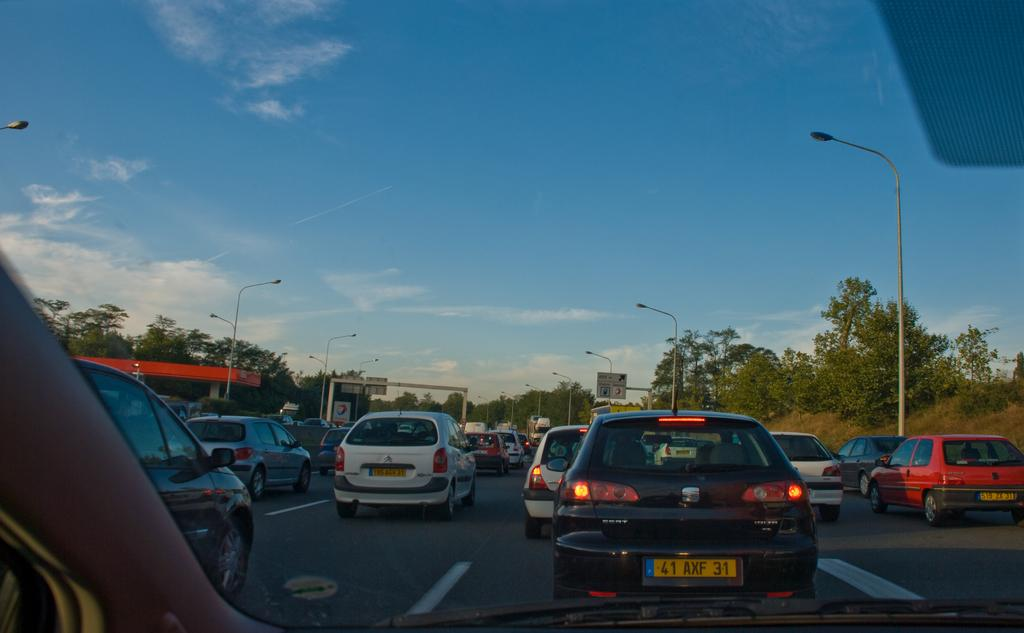What can be seen on the road in the image? There is a group of vehicles on the road in the image. What architectural feature is present in the image? There is a roof with a pillar in the image. What type of structures can be seen along the road? There are street poles in the image. What type of information might be conveyed by the objects in the image? There are signboards in the image, which might convey information or directions. What type of vegetation is present in the image? There is a group of trees in the image. What is the condition of the sky in the image? The sky is visible in the image and appears cloudy. What type of fruit is hanging from the street poles in the image? There is no fruit hanging from the street poles in the image; they are simply structures supporting wires or cables. What type of voyage is depicted in the image? There is no voyage depicted in the image; it is a static scene featuring vehicles, buildings, and trees. 